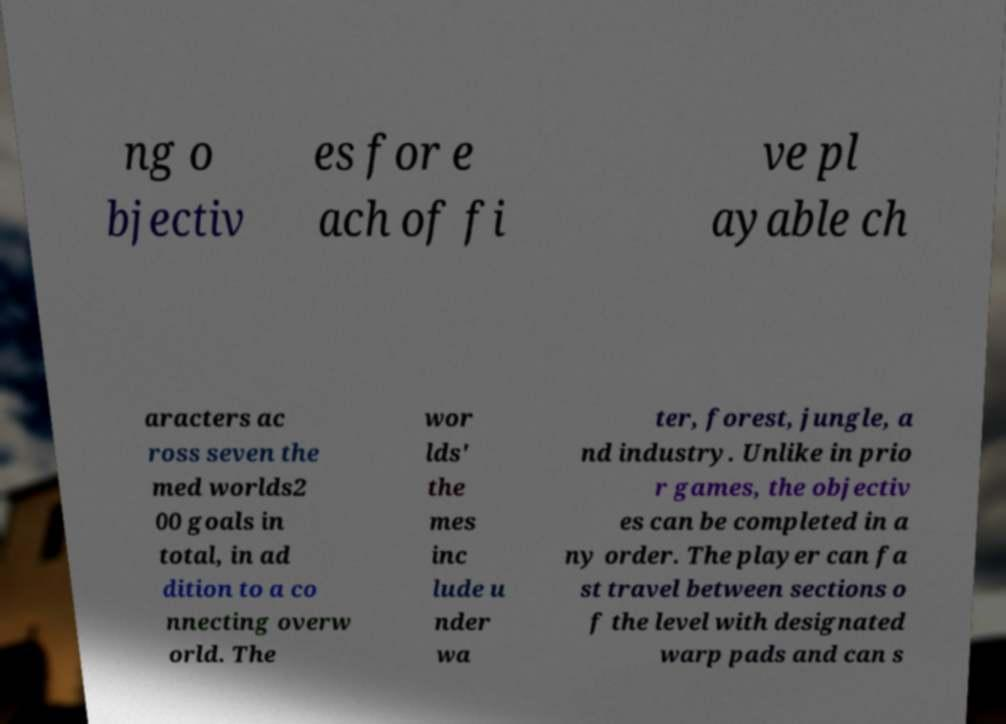What messages or text are displayed in this image? I need them in a readable, typed format. ng o bjectiv es for e ach of fi ve pl ayable ch aracters ac ross seven the med worlds2 00 goals in total, in ad dition to a co nnecting overw orld. The wor lds' the mes inc lude u nder wa ter, forest, jungle, a nd industry. Unlike in prio r games, the objectiv es can be completed in a ny order. The player can fa st travel between sections o f the level with designated warp pads and can s 